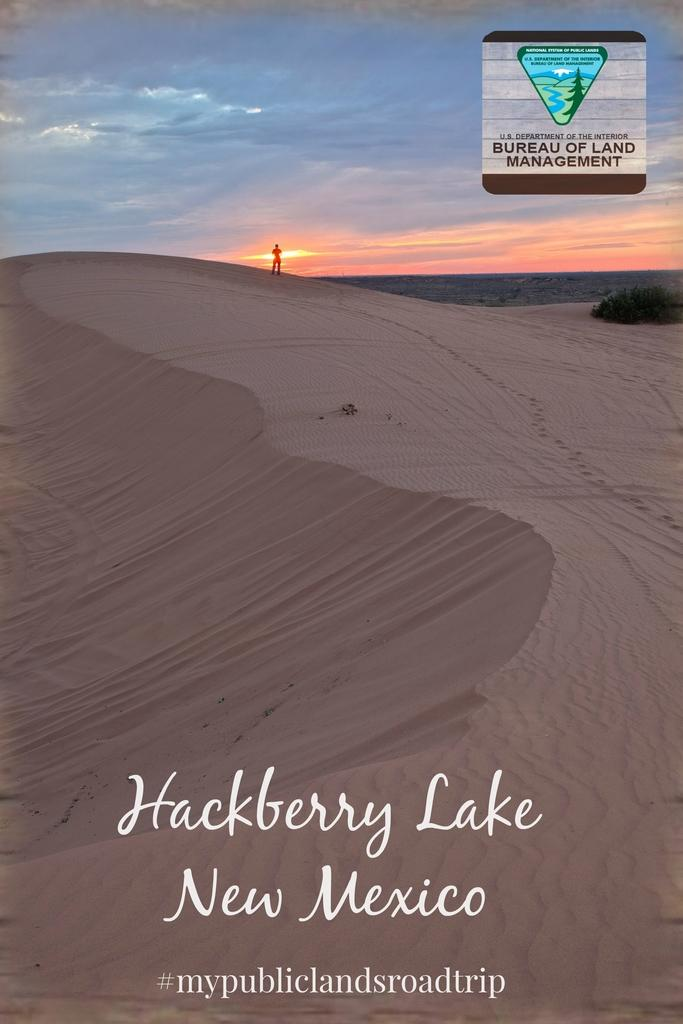<image>
Create a compact narrative representing the image presented. SAND DUNES WITH LOGO OF BUREAU OF LAND MANAGEMENT IN THE TOP RIGHT CORNER 